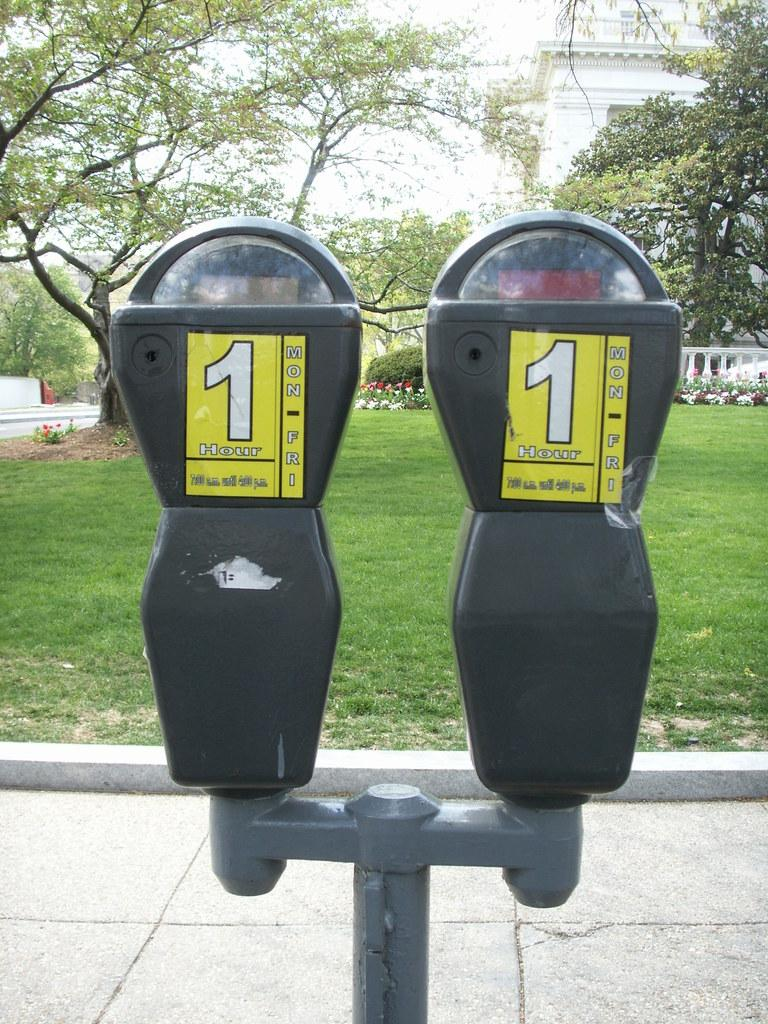Provide a one-sentence caption for the provided image. Two parking meters with 1 hour yellow stickers. 